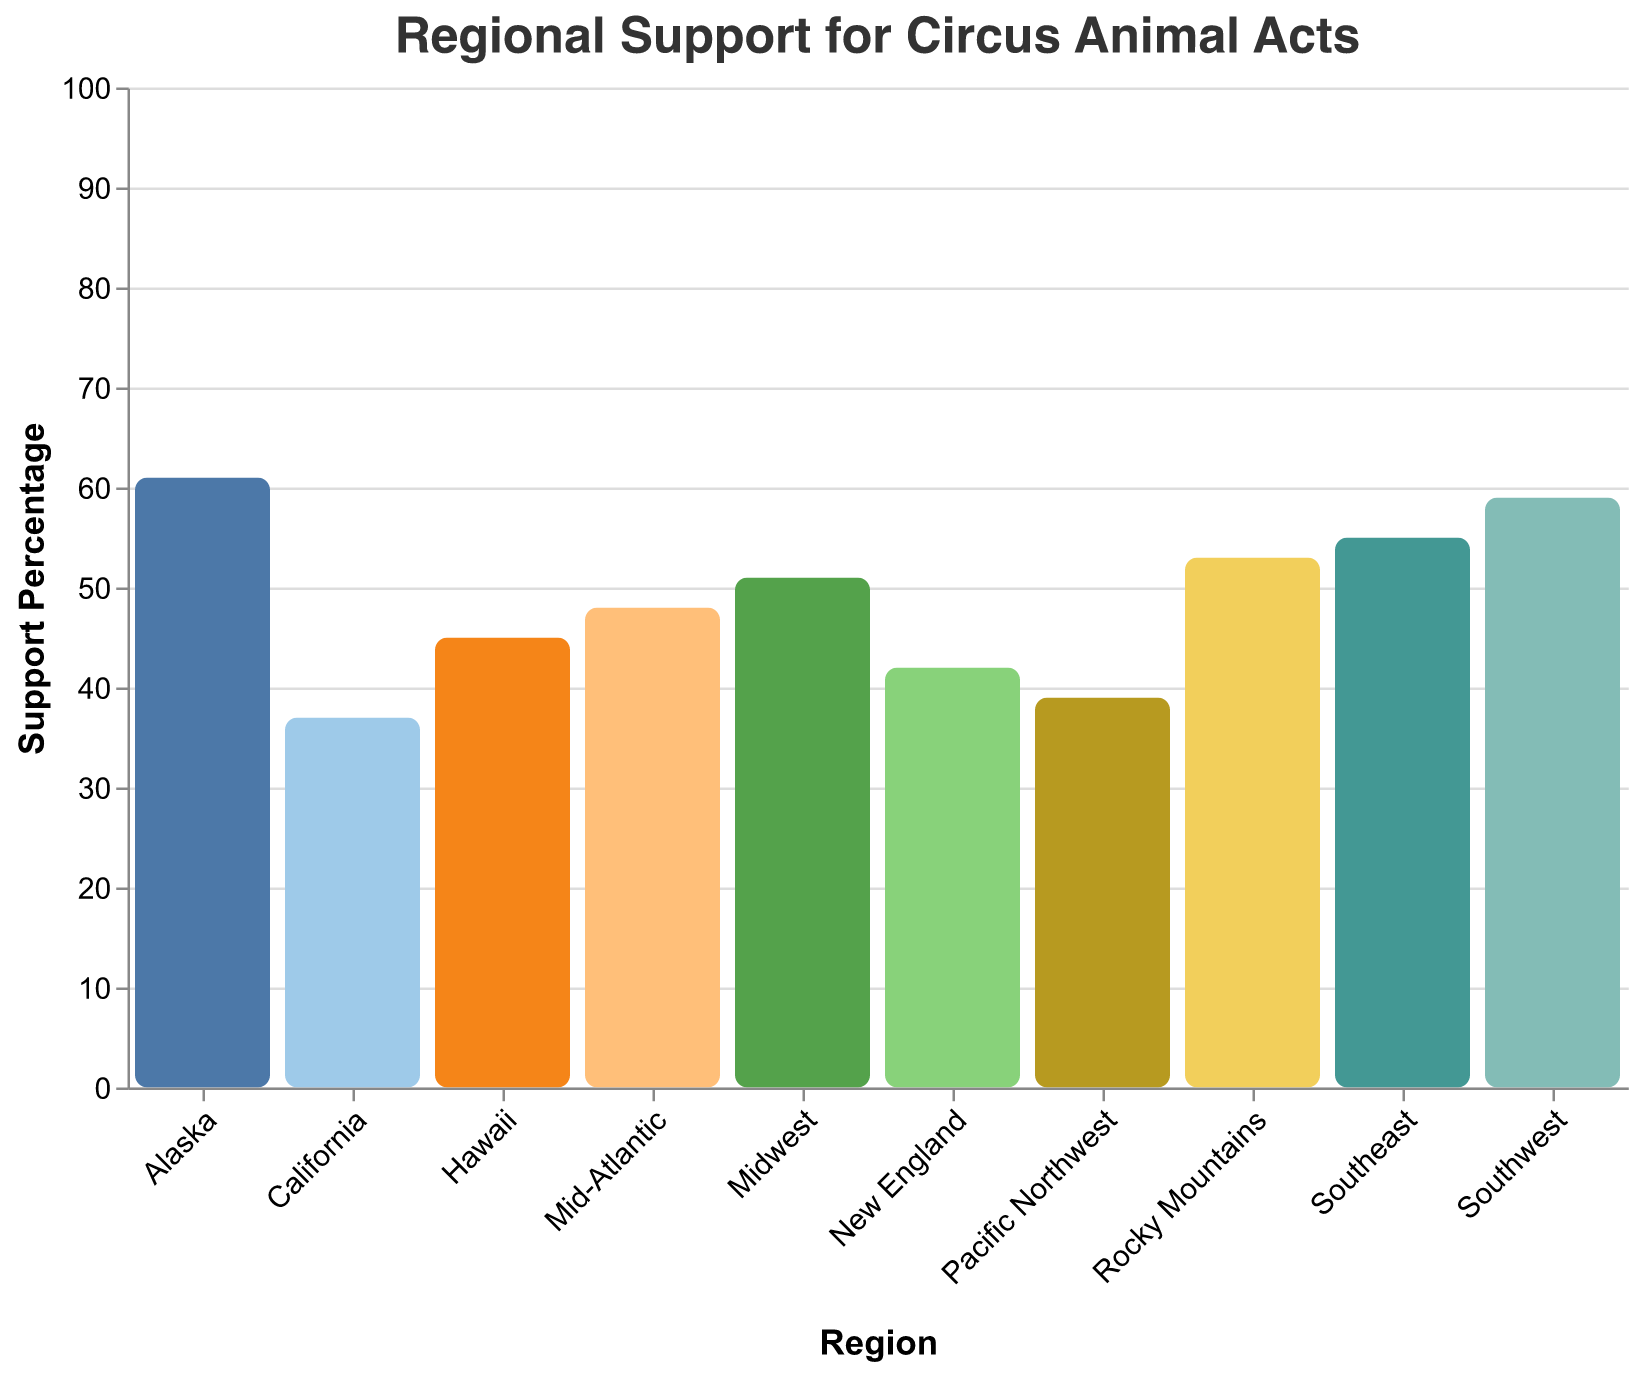What is the title of the figure? The title of the figure is usually located at the top and provides a summary of what the figure displays. In this case, it reads "Regional Support for Circus Animal Acts."
Answer: Regional Support for Circus Animal Acts Which region has the highest support percentage for circus animal acts? Identify the highest support percentage value by scanning the heights of the bars and locating the corresponding region. Alaska has the highest support percentage at 61%.
Answer: Alaska What is the difference in support percentage between the Southwest and the Pacific Northwest? Locate the support percentages of the Southwest (59%) and the Pacific Northwest (39%). The difference is calculated as 59% - 39%.
Answer: 20% How many regions have a support percentage greater than 50%? Count the number of regions where the support percentage bar exceeds the 50% mark. The regions are Southeast, Southwest, Rocky Mountains, Midwest, and Alaska, which totals to five regions.
Answer: 5 Which region has the lowest support percentage, and what is that percentage? Identify the shortest bar to find the lowest support percentage. California has the lowest support percentage at 37%.
Answer: California, 37% What is the median support percentage of all regions? List the support percentages: 37, 39, 42, 45, 48, 51, 53, 55, 59, 61. The median is the middle value of an ordered list. The median of the dataset (sorted in ascending order) is the average of the 5th and 6th values, (48 + 51) / 2.
Answer: 49.5% Are there more regions with opposition percentages greater or less than 50%? Count regions with opposition percentages greater than 50% (New England, Mid-Atlantic, Pacific Northwest, California, Hawaii) and less than 50% (Southeast, Midwest, Southwest, Rocky Mountains, Alaska). Both counts are equal.
Answer: Equal number, 5 each How does the support percentage in New England compare to that in Hawaii? Compare the support percentages directly by locating the corresponding bars. New England has 42% support, and Hawaii has 45% support. Hawaii has a slightly higher support percentage.
Answer: Hawaii is higher What is the average support percentage across all regions? Sum all the support percentages (42 + 48 + 55 + 51 + 59 + 53 + 39 + 37 + 61 + 45) and divide by the number of regions (10). The sum is 490, so the average is 490 / 10.
Answer: 49% Is the support for circus animal acts higher in the Southeast, or in the Midwest? Directly compare the support percentages by examining the bar heights. The Southeast has a support percentage of 55%, and the Midwest has 51%. The Southeast has higher support.
Answer: Southeast 